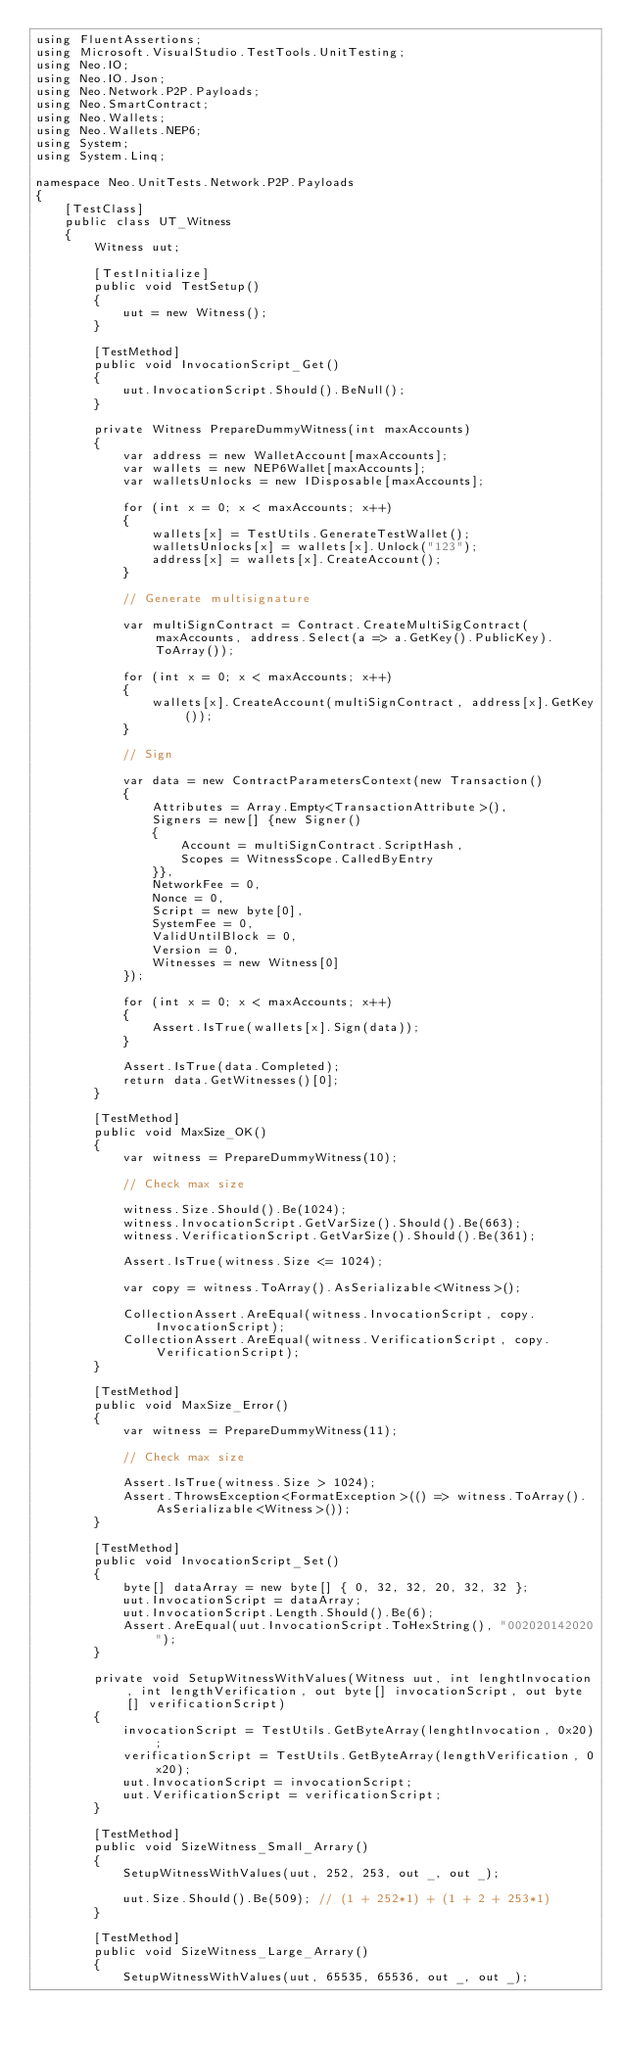Convert code to text. <code><loc_0><loc_0><loc_500><loc_500><_C#_>using FluentAssertions;
using Microsoft.VisualStudio.TestTools.UnitTesting;
using Neo.IO;
using Neo.IO.Json;
using Neo.Network.P2P.Payloads;
using Neo.SmartContract;
using Neo.Wallets;
using Neo.Wallets.NEP6;
using System;
using System.Linq;

namespace Neo.UnitTests.Network.P2P.Payloads
{
    [TestClass]
    public class UT_Witness
    {
        Witness uut;

        [TestInitialize]
        public void TestSetup()
        {
            uut = new Witness();
        }

        [TestMethod]
        public void InvocationScript_Get()
        {
            uut.InvocationScript.Should().BeNull();
        }

        private Witness PrepareDummyWitness(int maxAccounts)
        {
            var address = new WalletAccount[maxAccounts];
            var wallets = new NEP6Wallet[maxAccounts];
            var walletsUnlocks = new IDisposable[maxAccounts];

            for (int x = 0; x < maxAccounts; x++)
            {
                wallets[x] = TestUtils.GenerateTestWallet();
                walletsUnlocks[x] = wallets[x].Unlock("123");
                address[x] = wallets[x].CreateAccount();
            }

            // Generate multisignature

            var multiSignContract = Contract.CreateMultiSigContract(maxAccounts, address.Select(a => a.GetKey().PublicKey).ToArray());

            for (int x = 0; x < maxAccounts; x++)
            {
                wallets[x].CreateAccount(multiSignContract, address[x].GetKey());
            }

            // Sign

            var data = new ContractParametersContext(new Transaction()
            {
                Attributes = Array.Empty<TransactionAttribute>(),
                Signers = new[] {new Signer()
                {
                    Account = multiSignContract.ScriptHash,
                    Scopes = WitnessScope.CalledByEntry
                }},
                NetworkFee = 0,
                Nonce = 0,
                Script = new byte[0],
                SystemFee = 0,
                ValidUntilBlock = 0,
                Version = 0,
                Witnesses = new Witness[0]
            });

            for (int x = 0; x < maxAccounts; x++)
            {
                Assert.IsTrue(wallets[x].Sign(data));
            }

            Assert.IsTrue(data.Completed);
            return data.GetWitnesses()[0];
        }

        [TestMethod]
        public void MaxSize_OK()
        {
            var witness = PrepareDummyWitness(10);

            // Check max size

            witness.Size.Should().Be(1024);
            witness.InvocationScript.GetVarSize().Should().Be(663);
            witness.VerificationScript.GetVarSize().Should().Be(361);

            Assert.IsTrue(witness.Size <= 1024);

            var copy = witness.ToArray().AsSerializable<Witness>();

            CollectionAssert.AreEqual(witness.InvocationScript, copy.InvocationScript);
            CollectionAssert.AreEqual(witness.VerificationScript, copy.VerificationScript);
        }

        [TestMethod]
        public void MaxSize_Error()
        {
            var witness = PrepareDummyWitness(11);

            // Check max size

            Assert.IsTrue(witness.Size > 1024);
            Assert.ThrowsException<FormatException>(() => witness.ToArray().AsSerializable<Witness>());
        }

        [TestMethod]
        public void InvocationScript_Set()
        {
            byte[] dataArray = new byte[] { 0, 32, 32, 20, 32, 32 };
            uut.InvocationScript = dataArray;
            uut.InvocationScript.Length.Should().Be(6);
            Assert.AreEqual(uut.InvocationScript.ToHexString(), "002020142020");
        }

        private void SetupWitnessWithValues(Witness uut, int lenghtInvocation, int lengthVerification, out byte[] invocationScript, out byte[] verificationScript)
        {
            invocationScript = TestUtils.GetByteArray(lenghtInvocation, 0x20);
            verificationScript = TestUtils.GetByteArray(lengthVerification, 0x20);
            uut.InvocationScript = invocationScript;
            uut.VerificationScript = verificationScript;
        }

        [TestMethod]
        public void SizeWitness_Small_Arrary()
        {
            SetupWitnessWithValues(uut, 252, 253, out _, out _);

            uut.Size.Should().Be(509); // (1 + 252*1) + (1 + 2 + 253*1)
        }

        [TestMethod]
        public void SizeWitness_Large_Arrary()
        {
            SetupWitnessWithValues(uut, 65535, 65536, out _, out _);
</code> 